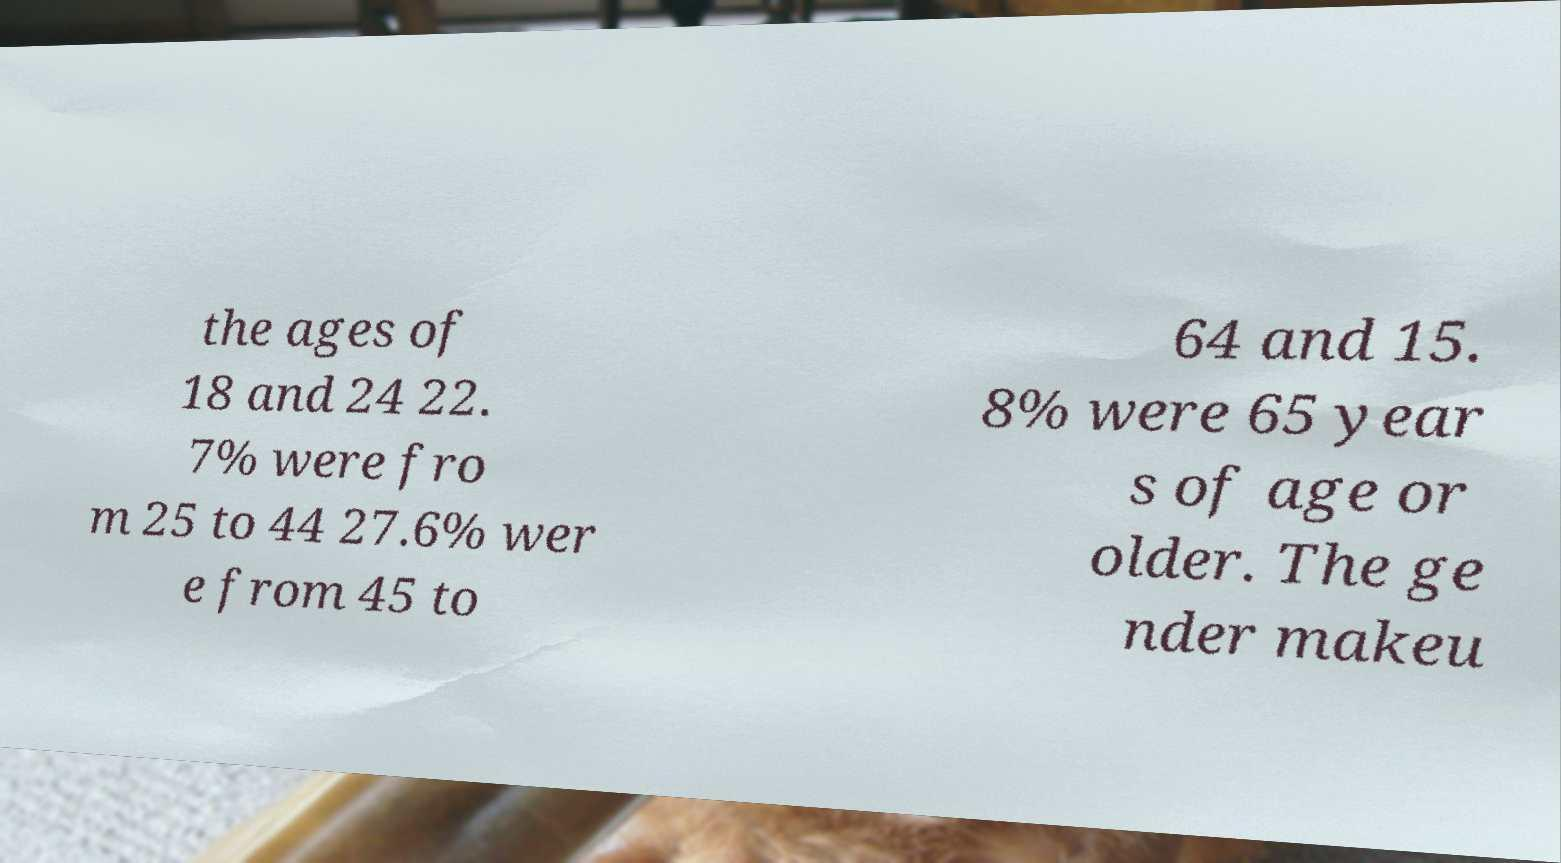Could you extract and type out the text from this image? the ages of 18 and 24 22. 7% were fro m 25 to 44 27.6% wer e from 45 to 64 and 15. 8% were 65 year s of age or older. The ge nder makeu 